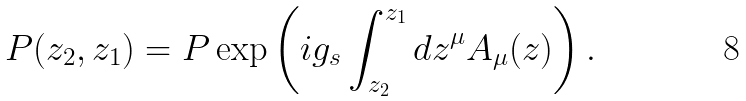Convert formula to latex. <formula><loc_0><loc_0><loc_500><loc_500>P ( z _ { 2 } , z _ { 1 } ) = P \exp \left ( i g _ { s } \int _ { z _ { 2 } } ^ { z _ { 1 } } d z ^ { \mu } A _ { \mu } ( z ) \right ) .</formula> 